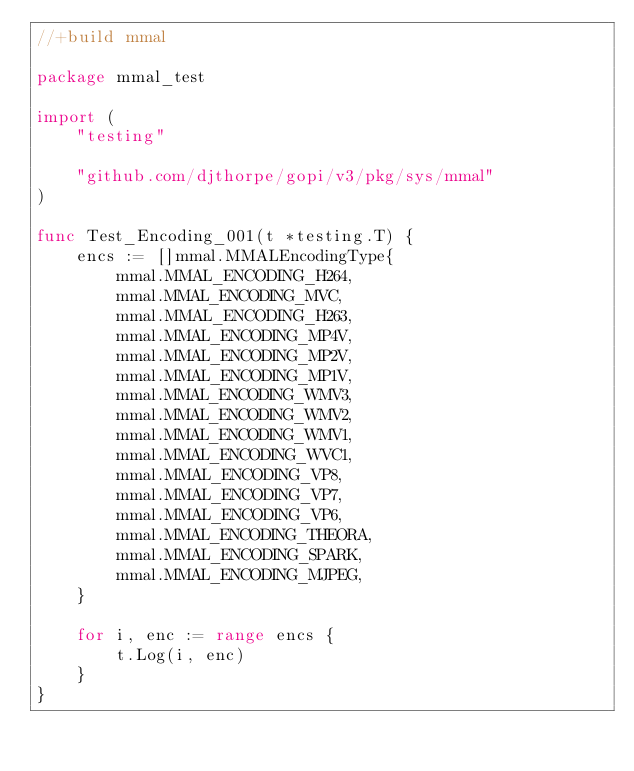<code> <loc_0><loc_0><loc_500><loc_500><_Go_>//+build mmal

package mmal_test

import (
	"testing"

	"github.com/djthorpe/gopi/v3/pkg/sys/mmal"
)

func Test_Encoding_001(t *testing.T) {
	encs := []mmal.MMALEncodingType{
		mmal.MMAL_ENCODING_H264,
		mmal.MMAL_ENCODING_MVC,
		mmal.MMAL_ENCODING_H263,
		mmal.MMAL_ENCODING_MP4V,
		mmal.MMAL_ENCODING_MP2V,
		mmal.MMAL_ENCODING_MP1V,
		mmal.MMAL_ENCODING_WMV3,
		mmal.MMAL_ENCODING_WMV2,
		mmal.MMAL_ENCODING_WMV1,
		mmal.MMAL_ENCODING_WVC1,
		mmal.MMAL_ENCODING_VP8,
		mmal.MMAL_ENCODING_VP7,
		mmal.MMAL_ENCODING_VP6,
		mmal.MMAL_ENCODING_THEORA,
		mmal.MMAL_ENCODING_SPARK,
		mmal.MMAL_ENCODING_MJPEG,
	}

	for i, enc := range encs {
		t.Log(i, enc)
	}
}
</code> 